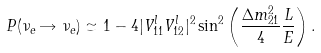Convert formula to latex. <formula><loc_0><loc_0><loc_500><loc_500>P ( \nu _ { e } \rightarrow \nu _ { e } ) \simeq 1 - 4 | V ^ { l } _ { 1 1 } V ^ { l } _ { 1 2 } | ^ { 2 } \sin ^ { 2 } \left ( \frac { \Delta m ^ { 2 } _ { 2 1 } } { 4 } \frac { L } { E } \right ) .</formula> 